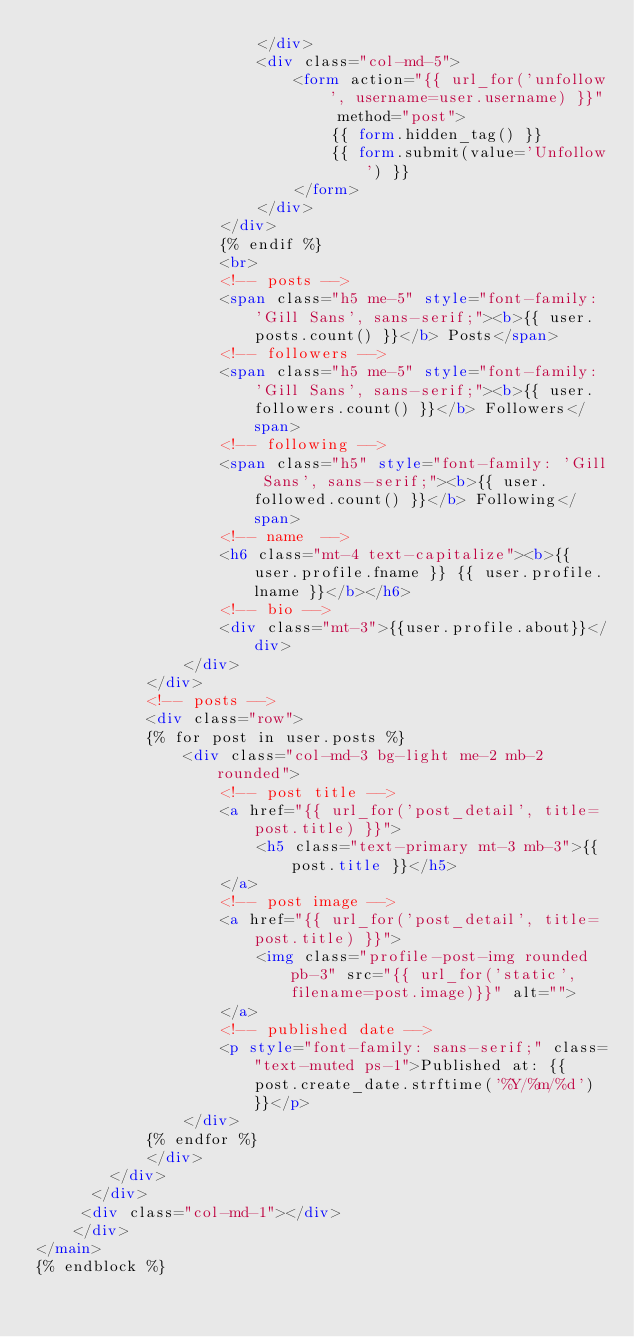<code> <loc_0><loc_0><loc_500><loc_500><_HTML_>                        </div>
                        <div class="col-md-5">
                            <form action="{{ url_for('unfollow', username=user.username) }}" method="post">
                                {{ form.hidden_tag() }}
                                {{ form.submit(value='Unfollow') }}
                            </form>
                        </div>
                    </div>
                    {% endif %}
                    <br>
                    <!-- posts -->
                    <span class="h5 me-5" style="font-family: 'Gill Sans', sans-serif;"><b>{{ user.posts.count() }}</b> Posts</span>
                    <!-- followers -->
                    <span class="h5 me-5" style="font-family: 'Gill Sans', sans-serif;"><b>{{ user.followers.count() }}</b> Followers</span>
                    <!-- following -->
                    <span class="h5" style="font-family: 'Gill Sans', sans-serif;"><b>{{ user.followed.count() }}</b> Following</span>
                    <!-- name  -->
                    <h6 class="mt-4 text-capitalize"><b>{{ user.profile.fname }} {{ user.profile.lname }}</b></h6>
                    <!-- bio -->
                    <div class="mt-3">{{user.profile.about}}</div>
                </div>
            </div>
            <!-- posts -->
            <div class="row">
            {% for post in user.posts %}
                <div class="col-md-3 bg-light me-2 mb-2 rounded">
                    <!-- post title -->
                    <a href="{{ url_for('post_detail', title=post.title) }}">
                        <h5 class="text-primary mt-3 mb-3">{{ post.title }}</h5>
                    </a>
                    <!-- post image -->
                    <a href="{{ url_for('post_detail', title=post.title) }}">
                        <img class="profile-post-img rounded pb-3" src="{{ url_for('static', filename=post.image)}}" alt="">
                    </a>
                    <!-- published date -->
                    <p style="font-family: sans-serif;" class="text-muted ps-1">Published at: {{ post.create_date.strftime('%Y/%m/%d') }}</p>
                </div>
            {% endfor %}
            </div>
        </div>
      </div>
     <div class="col-md-1"></div>
    </div>
</main> 
{% endblock %}
</code> 